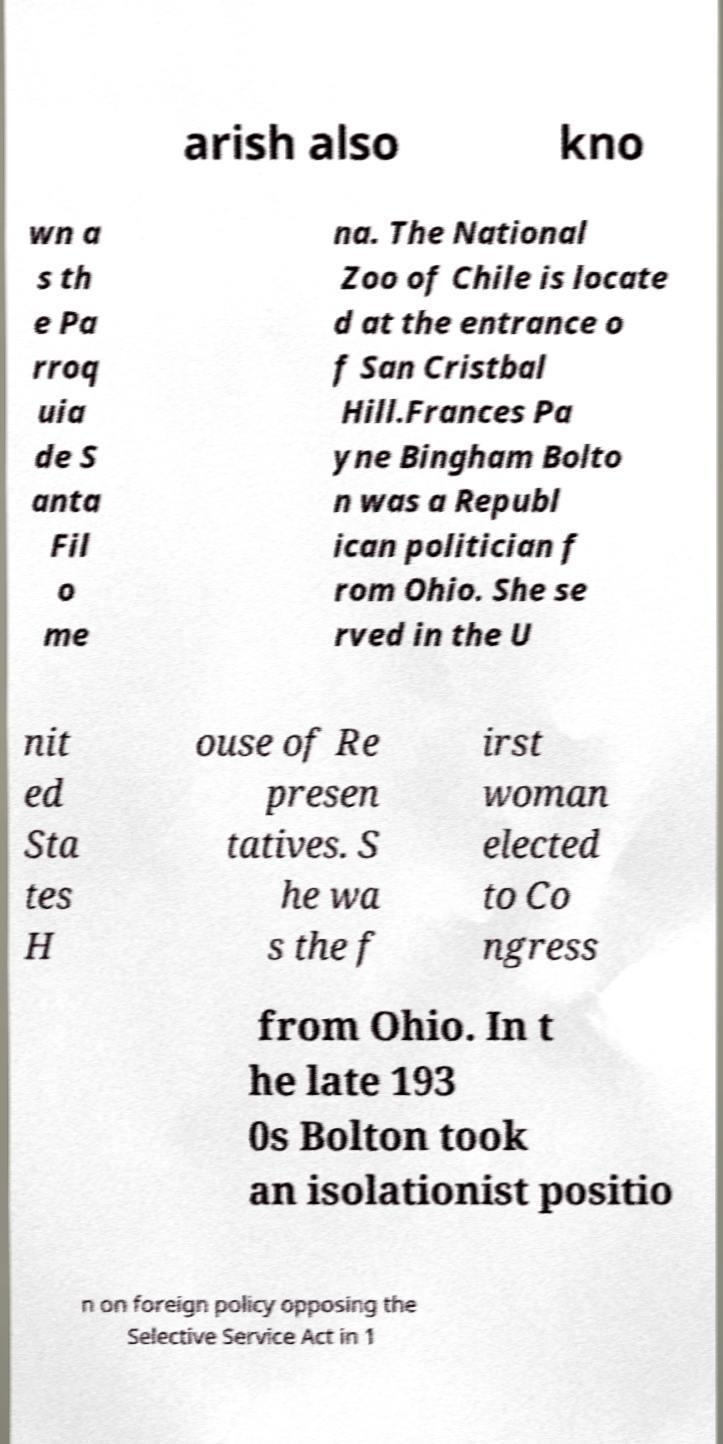For documentation purposes, I need the text within this image transcribed. Could you provide that? arish also kno wn a s th e Pa rroq uia de S anta Fil o me na. The National Zoo of Chile is locate d at the entrance o f San Cristbal Hill.Frances Pa yne Bingham Bolto n was a Republ ican politician f rom Ohio. She se rved in the U nit ed Sta tes H ouse of Re presen tatives. S he wa s the f irst woman elected to Co ngress from Ohio. In t he late 193 0s Bolton took an isolationist positio n on foreign policy opposing the Selective Service Act in 1 